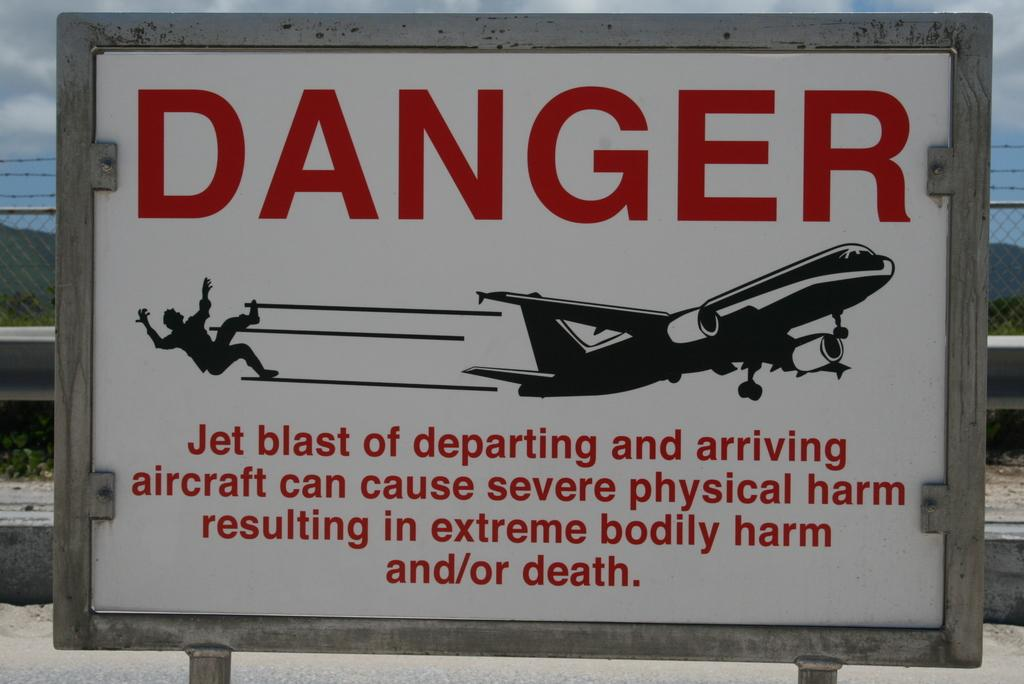What type of board is present in the image? There is a white color danger board in the image. What can be seen in the background of the image? The background of the image includes railing. What colors are visible in the sky in the image? The sky is visible in the background of the image, with white and blue colors. Can you see a kitty playing with a pie in the image? There is no kitty or pie present in the image. What is the purpose of the protest sign in the image? There is no protest sign in the image; it features a white color danger board. 